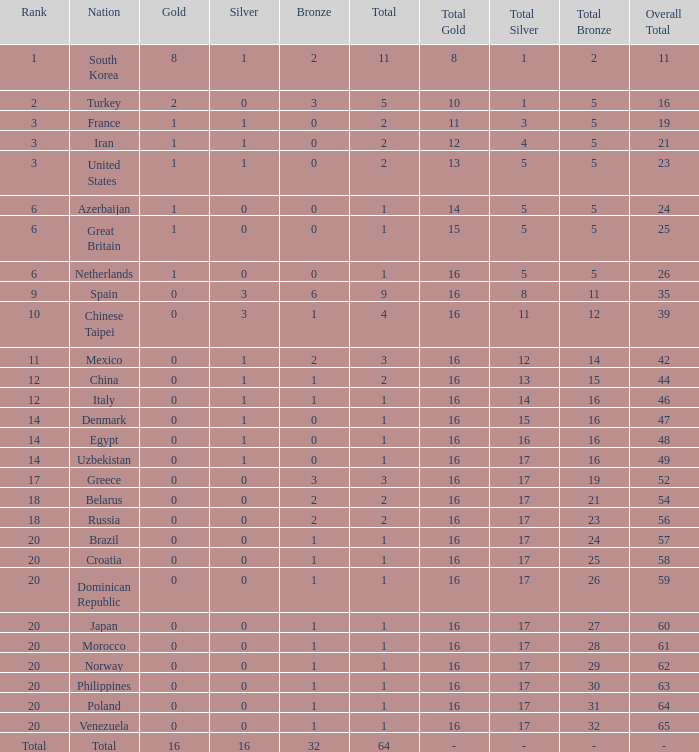What is the average total medals of the nation ranked 1 with less than 1 silver? None. 